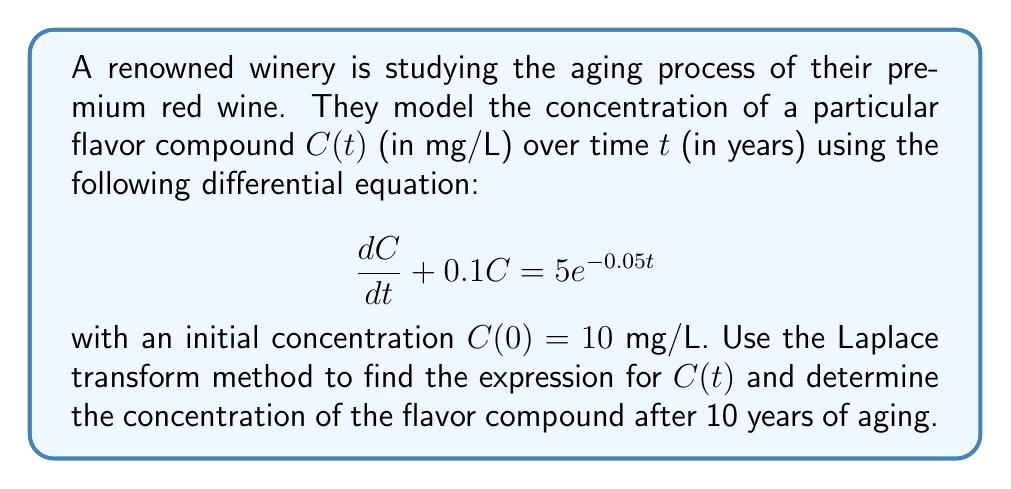Solve this math problem. Let's solve this problem step by step using the Laplace transform method:

1) First, we take the Laplace transform of both sides of the differential equation:

   $\mathcal{L}\{\frac{dC}{dt} + 0.1C\} = \mathcal{L}\{5e^{-0.05t}\}$

2) Using the linearity property and the Laplace transform of the derivative:

   $s\mathcal{L}\{C\} - C(0) + 0.1\mathcal{L}\{C\} = \frac{5}{s+0.05}$

3) Let $\mathcal{L}\{C\} = \bar{C}(s)$. Substituting the initial condition $C(0) = 10$:

   $s\bar{C}(s) - 10 + 0.1\bar{C}(s) = \frac{5}{s+0.05}$

4) Factoring out $\bar{C}(s)$:

   $(s + 0.1)\bar{C}(s) = \frac{5}{s+0.05} + 10$

5) Solving for $\bar{C}(s)$:

   $\bar{C}(s) = \frac{5}{(s+0.1)(s+0.05)} + \frac{10}{s+0.1}$

6) Using partial fraction decomposition:

   $\bar{C}(s) = \frac{100}{s+0.1} - \frac{100}{s+0.05} + \frac{10}{s+0.1}$

   $\bar{C}(s) = \frac{110}{s+0.1} - \frac{100}{s+0.05}$

7) Taking the inverse Laplace transform:

   $C(t) = 110e^{-0.1t} - 100e^{-0.05t}$

8) To find the concentration after 10 years, we substitute $t = 10$:

   $C(10) = 110e^{-0.1(10)} - 100e^{-0.05(10)}$
          $= 110e^{-1} - 100e^{-0.5}$
          $\approx 40.5 - 60.7$
          $\approx -20.2$ mg/L

However, since concentration cannot be negative, we interpret this result as the flavor compound being completely depleted after 10 years.
Answer: The expression for the concentration of the flavor compound over time is:

$$C(t) = 110e^{-0.1t} - 100e^{-0.05t}$$

After 10 years of aging, the concentration of the flavor compound is effectively 0 mg/L, as the compound has been completely depleted. 